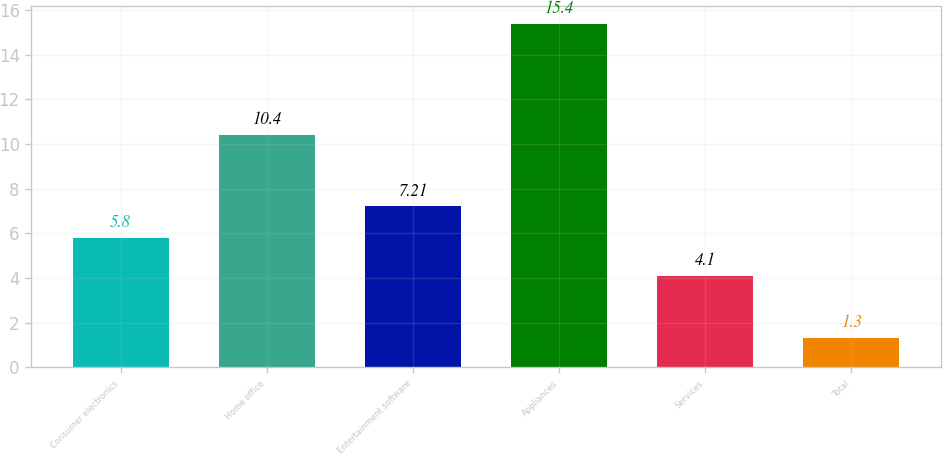<chart> <loc_0><loc_0><loc_500><loc_500><bar_chart><fcel>Consumer electronics<fcel>Home office<fcel>Entertainment software<fcel>Appliances<fcel>Services<fcel>Total<nl><fcel>5.8<fcel>10.4<fcel>7.21<fcel>15.4<fcel>4.1<fcel>1.3<nl></chart> 